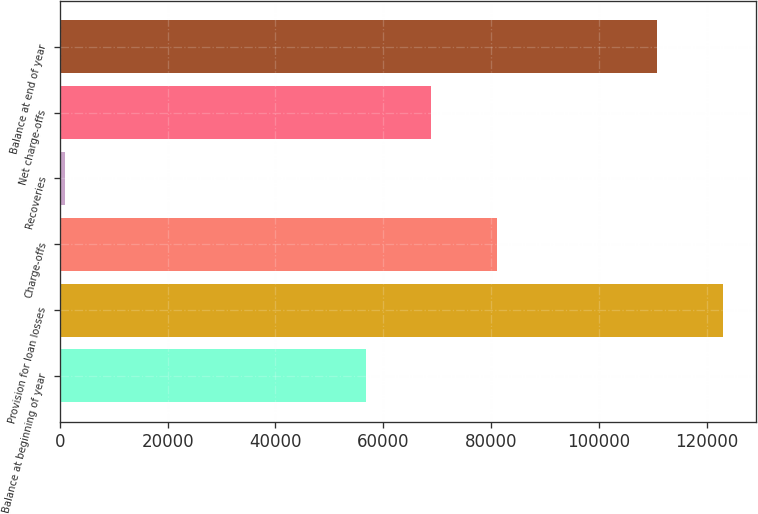<chart> <loc_0><loc_0><loc_500><loc_500><bar_chart><fcel>Balance at beginning of year<fcel>Provision for loan losses<fcel>Charge-offs<fcel>Recoveries<fcel>Net charge-offs<fcel>Balance at end of year<nl><fcel>56774<fcel>122936<fcel>81019.4<fcel>946<fcel>68896.7<fcel>110813<nl></chart> 